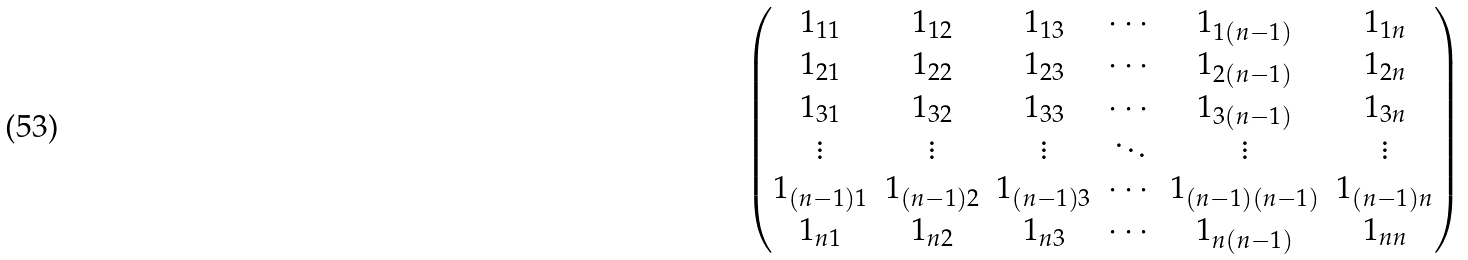Convert formula to latex. <formula><loc_0><loc_0><loc_500><loc_500>\begin{pmatrix} 1 _ { 1 1 } & 1 _ { 1 2 } & 1 _ { 1 3 } & \cdots & 1 _ { 1 ( n - 1 ) } & 1 _ { 1 n } \\ 1 _ { 2 1 } & 1 _ { 2 2 } & 1 _ { 2 3 } & \cdots & 1 _ { 2 ( n - 1 ) } & 1 _ { 2 n } \\ 1 _ { 3 1 } & 1 _ { 3 2 } & 1 _ { 3 3 } & \cdots & 1 _ { 3 ( n - 1 ) } & 1 _ { 3 n } \\ \vdots & \vdots & \vdots & \ddots & \vdots & \vdots \\ 1 _ { ( n - 1 ) 1 } & 1 _ { ( n - 1 ) 2 } & 1 _ { ( n - 1 ) 3 } & \cdots & 1 _ { ( n - 1 ) ( n - 1 ) } & 1 _ { ( n - 1 ) n } \\ 1 _ { n 1 } & 1 _ { n 2 } & 1 _ { n 3 } & \cdots & 1 _ { n ( n - 1 ) } & 1 _ { n n } \\ \end{pmatrix}</formula> 